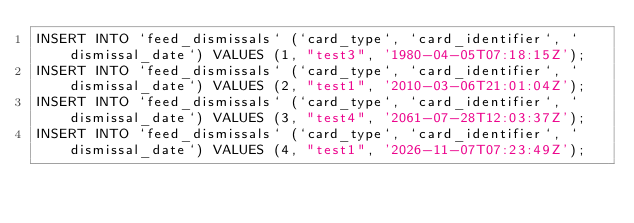Convert code to text. <code><loc_0><loc_0><loc_500><loc_500><_SQL_>INSERT INTO `feed_dismissals` (`card_type`, `card_identifier`, `dismissal_date`) VALUES (1, "test3", '1980-04-05T07:18:15Z');
INSERT INTO `feed_dismissals` (`card_type`, `card_identifier`, `dismissal_date`) VALUES (2, "test1", '2010-03-06T21:01:04Z');
INSERT INTO `feed_dismissals` (`card_type`, `card_identifier`, `dismissal_date`) VALUES (3, "test4", '2061-07-28T12:03:37Z');
INSERT INTO `feed_dismissals` (`card_type`, `card_identifier`, `dismissal_date`) VALUES (4, "test1", '2026-11-07T07:23:49Z');</code> 